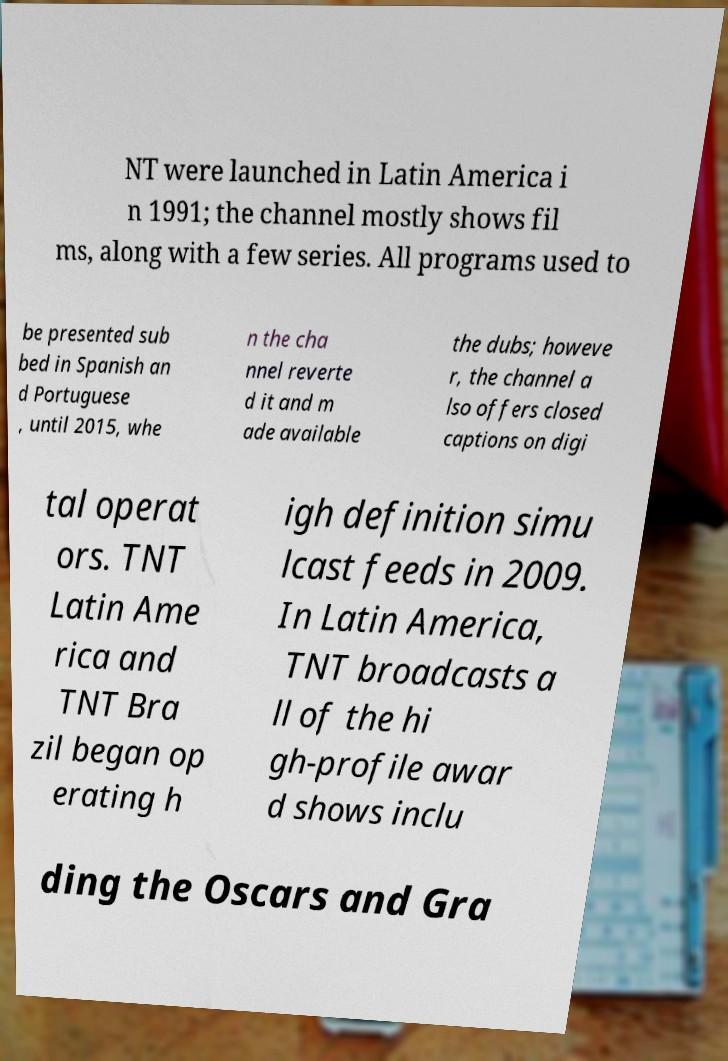Could you extract and type out the text from this image? NT were launched in Latin America i n 1991; the channel mostly shows fil ms, along with a few series. All programs used to be presented sub bed in Spanish an d Portuguese , until 2015, whe n the cha nnel reverte d it and m ade available the dubs; howeve r, the channel a lso offers closed captions on digi tal operat ors. TNT Latin Ame rica and TNT Bra zil began op erating h igh definition simu lcast feeds in 2009. In Latin America, TNT broadcasts a ll of the hi gh-profile awar d shows inclu ding the Oscars and Gra 